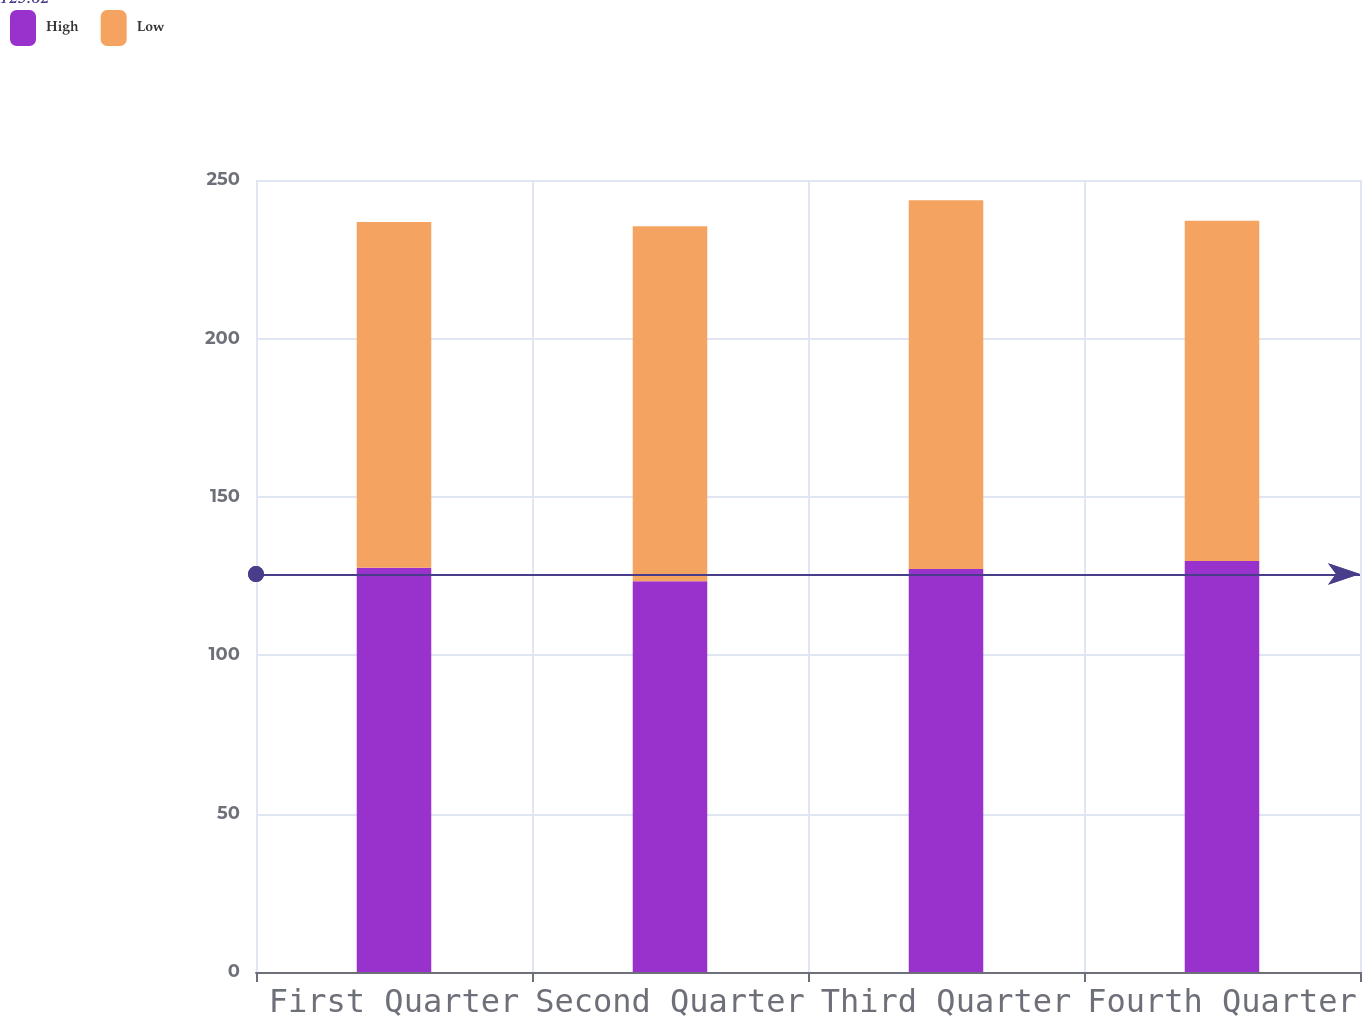<chart> <loc_0><loc_0><loc_500><loc_500><stacked_bar_chart><ecel><fcel>First Quarter<fcel>Second Quarter<fcel>Third Quarter<fcel>Fourth Quarter<nl><fcel>High<fcel>127.63<fcel>123.37<fcel>127.21<fcel>129.77<nl><fcel>Low<fcel>109.08<fcel>112.02<fcel>116.36<fcel>107.33<nl></chart> 